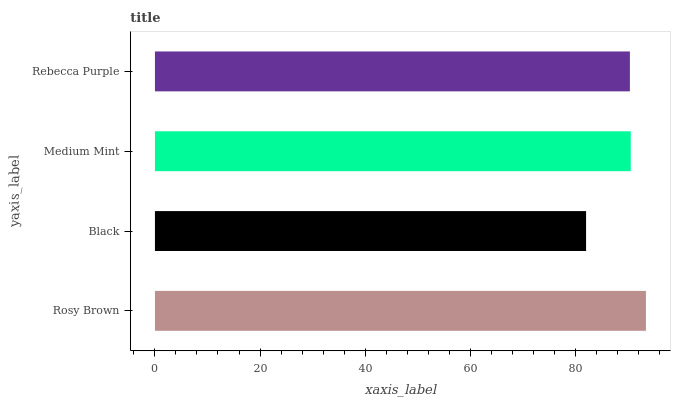Is Black the minimum?
Answer yes or no. Yes. Is Rosy Brown the maximum?
Answer yes or no. Yes. Is Medium Mint the minimum?
Answer yes or no. No. Is Medium Mint the maximum?
Answer yes or no. No. Is Medium Mint greater than Black?
Answer yes or no. Yes. Is Black less than Medium Mint?
Answer yes or no. Yes. Is Black greater than Medium Mint?
Answer yes or no. No. Is Medium Mint less than Black?
Answer yes or no. No. Is Medium Mint the high median?
Answer yes or no. Yes. Is Rebecca Purple the low median?
Answer yes or no. Yes. Is Black the high median?
Answer yes or no. No. Is Medium Mint the low median?
Answer yes or no. No. 